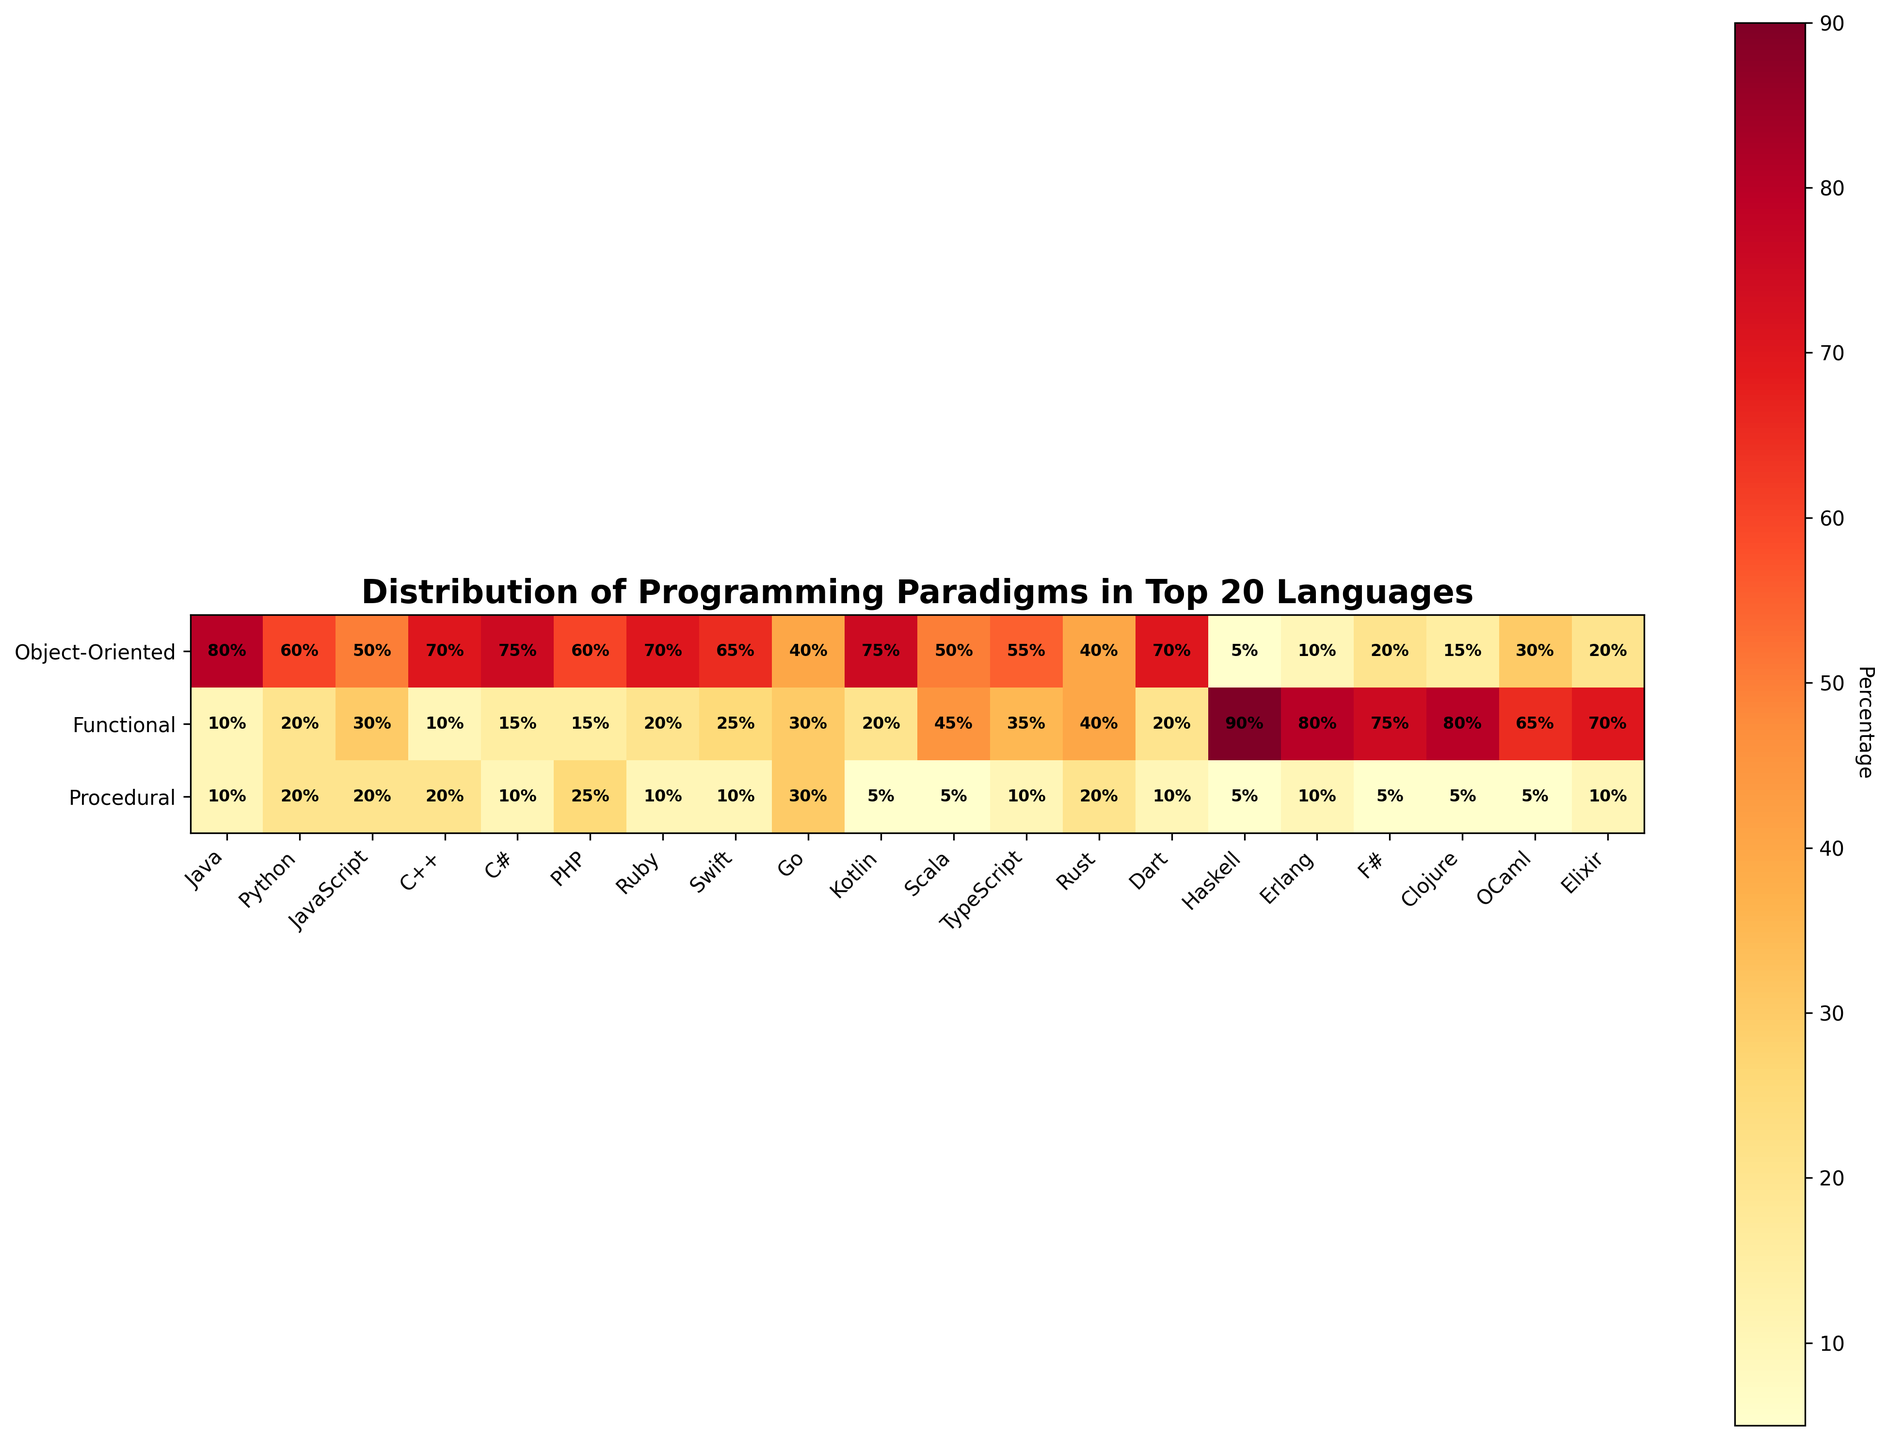what is the highest percentage value for Object-Oriented programming? Look at the rows corresponding to Object-Oriented programming, identify the highest percentage value, which is found under the "Language" Java with 80%.
Answer: 80% What is the title of the figure? The title can be found at the top of the figure, and it is typically in a larger, bold font size to stand out. In this case, it's "Distribution of Programming Paradigms in Top 20 Languages".
Answer: Distribution of Programming Paradigms in Top 20 Languages What is the common percentage for Procedural programming across JavaScript, PHP, Go, Rust, and Erlang? Identify the percentages for each mentioned language in the Procedural row: JavaScript (20%), PHP (25%), Go (30%), Rust (20%), and Erlang (10%). Calculate the sum: 20 + 25 + 30 + 20 + 10 = 105. The common percentage or the average is 105 / 5 = 21%.
Answer: 21% Which language shows a higher preference for Functional programming compared to Object-Oriented programming? Look for languages where the percentage for Functional programming (middle row) exceeds the percentage for Object-Oriented programming (top row). Identify languages such as Haskell, Erlang, F#, Clojure, OCaml, and Elixir.
Answer: Haskell, Erlang, F#, Clojure, OCaml, Elixir Between Java and Go, which language has a more balanced distribution across all three paradigms? Observe the percentage values for Java (80%, 10%, 10%) and Go (40%, 30%, 30%). Calculate the variances: Java: Variance = ((80-33.33)^2 + (10-33.33)^2 + (10-33.33)^2)/3 = ~1533.33; Go: Variance = ((40-33.33)^2 + (30-33.33)^2 + (30-33.33)^2)/3 =~ 18.89. Go has a lower variance, hence a more balanced distribution.
Answer: Go What programming paradigm is most associated with Scala? Locate Scala along the x-axis (i.e., the language label) and identify the largest percentage value among the paradigms. For Scala, the highest percentage is in Functional programming (45%).
Answer: Functional Which programming language has the lowest percentage of Object-Oriented programming? Look at the Object-Oriented row and identify the language with the smallest percentage. Haskell has the lowest percentage of Object-Oriented programming at 5%.
Answer: Haskell What is the combined percentage of Functional and Procedural paradigms for Python? Locate Python along the x-axis and sum the percentages of Functional (20%) and Procedural (20%) paradigms. The combined percentage is 20% + 20% = 40%.
Answer: 40% Compare the distribution of paradigms in Elixir and Ruby. Which has a more varied distribution? Compare the percentages: Elixir (20%, 70%, 10%) and Ruby (70%, 20%, 10%). Calculate variance: Elixir = ((20-33.33)^2 + (70-33.33)^2 + (10-33.33)^2)/3 = ~733.33; Ruby = ((70-33.33)^2 + (20-33.33)^2 + (10-33.33)^2)/3 =~ 822.22. Ruby has a more varied (higher variance) distribution.
Answer: Ruby Which programming language has an equal percentage of Object-Oriented and Procedural paradigms? Look for languages where the percentage values in the Object-Oriented and Procedural rows are equal. For instance, C++ (70% OO, 20% P) does not meet this criterion. JavaScript (50%, 20%), also doesn’t fit. Continue until finding no matching criteria. Hence, there's no language with equal percentages.
Answer: None 